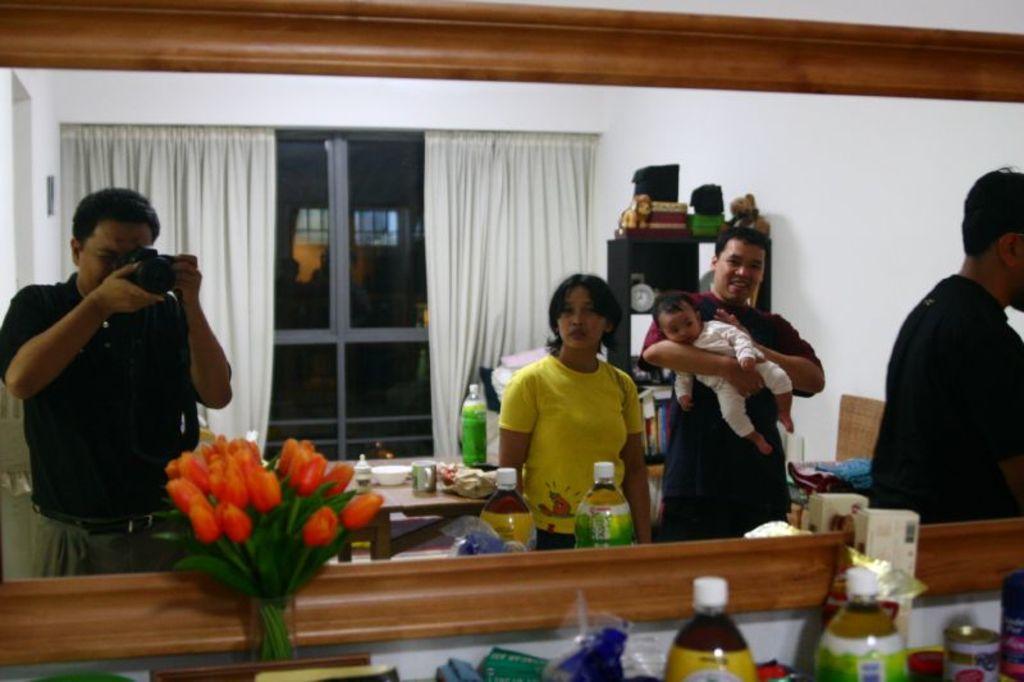Please provide a concise description of this image. In this picture there are four members in the room. One guy is taking a photograph with his camera. There is a table in the background with some food items and a bottle on it. Here are some flowers. In the background there is a curtain and a Windows here. 